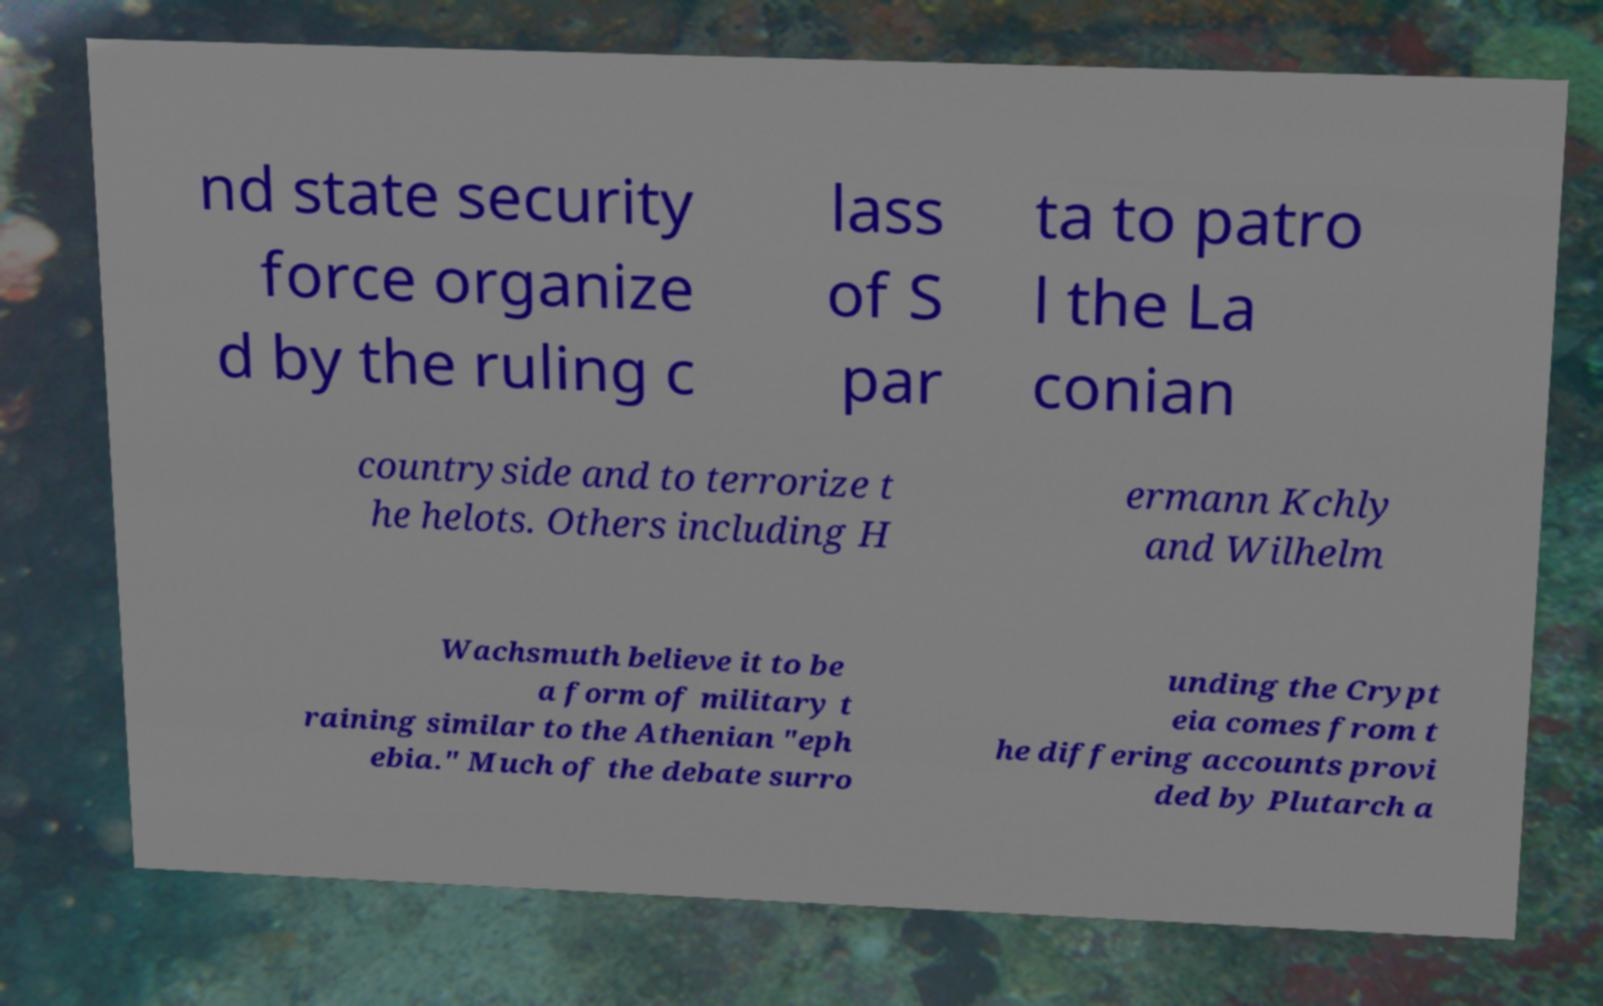Please read and relay the text visible in this image. What does it say? nd state security force organize d by the ruling c lass of S par ta to patro l the La conian countryside and to terrorize t he helots. Others including H ermann Kchly and Wilhelm Wachsmuth believe it to be a form of military t raining similar to the Athenian "eph ebia." Much of the debate surro unding the Crypt eia comes from t he differing accounts provi ded by Plutarch a 